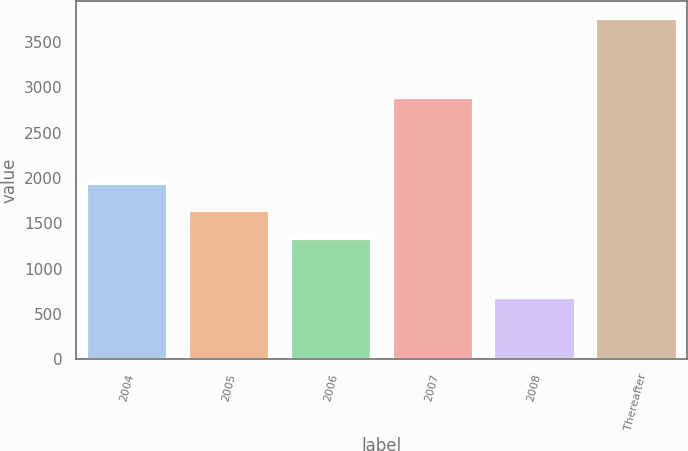<chart> <loc_0><loc_0><loc_500><loc_500><bar_chart><fcel>2004<fcel>2005<fcel>2006<fcel>2007<fcel>2008<fcel>Thereafter<nl><fcel>1950.8<fcel>1642.9<fcel>1335<fcel>2896<fcel>685<fcel>3764<nl></chart> 